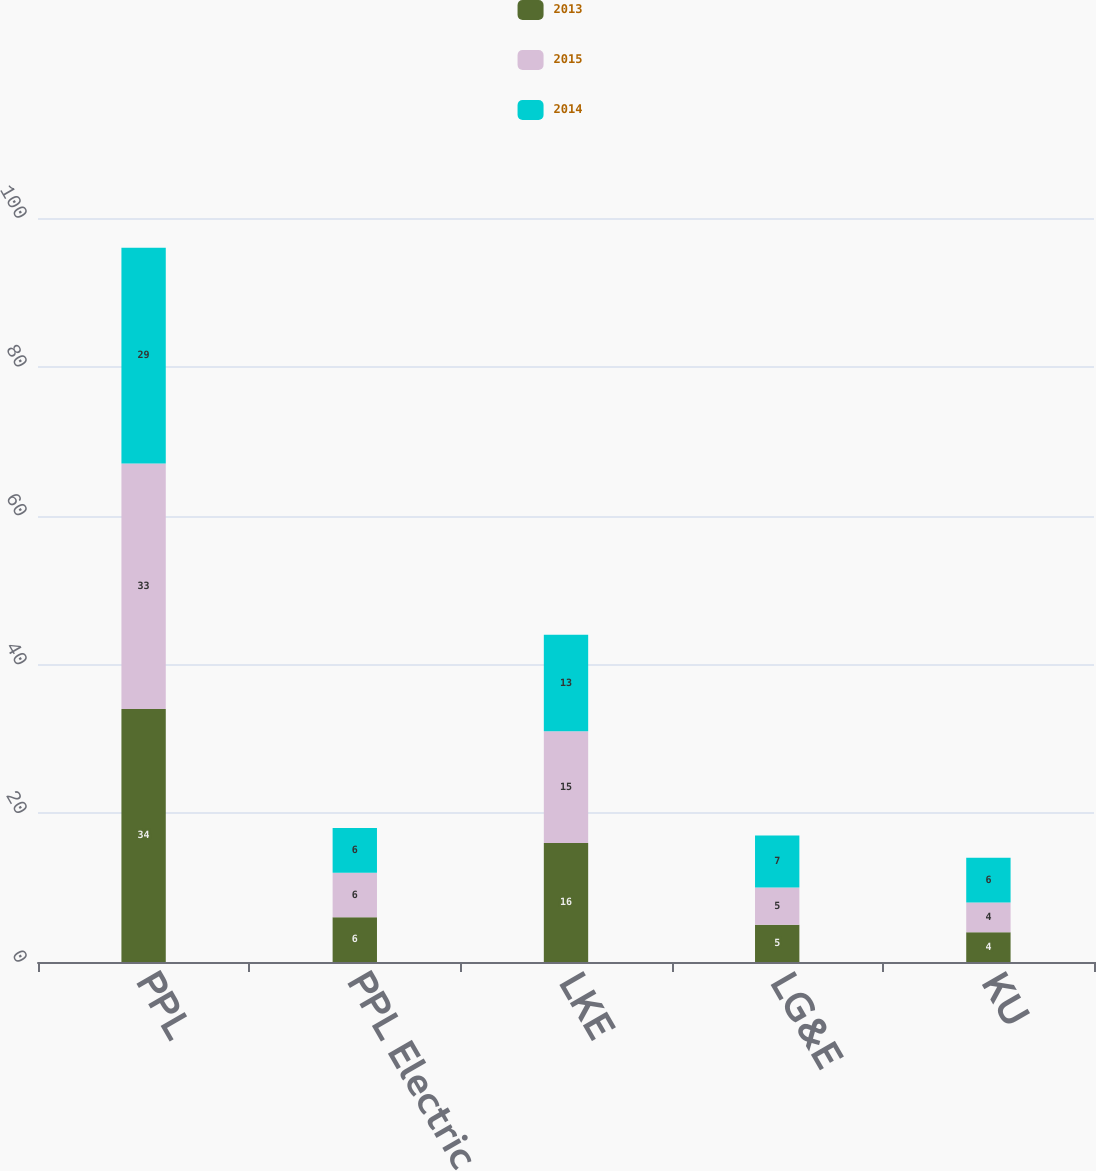Convert chart to OTSL. <chart><loc_0><loc_0><loc_500><loc_500><stacked_bar_chart><ecel><fcel>PPL<fcel>PPL Electric<fcel>LKE<fcel>LG&E<fcel>KU<nl><fcel>2013<fcel>34<fcel>6<fcel>16<fcel>5<fcel>4<nl><fcel>2015<fcel>33<fcel>6<fcel>15<fcel>5<fcel>4<nl><fcel>2014<fcel>29<fcel>6<fcel>13<fcel>7<fcel>6<nl></chart> 